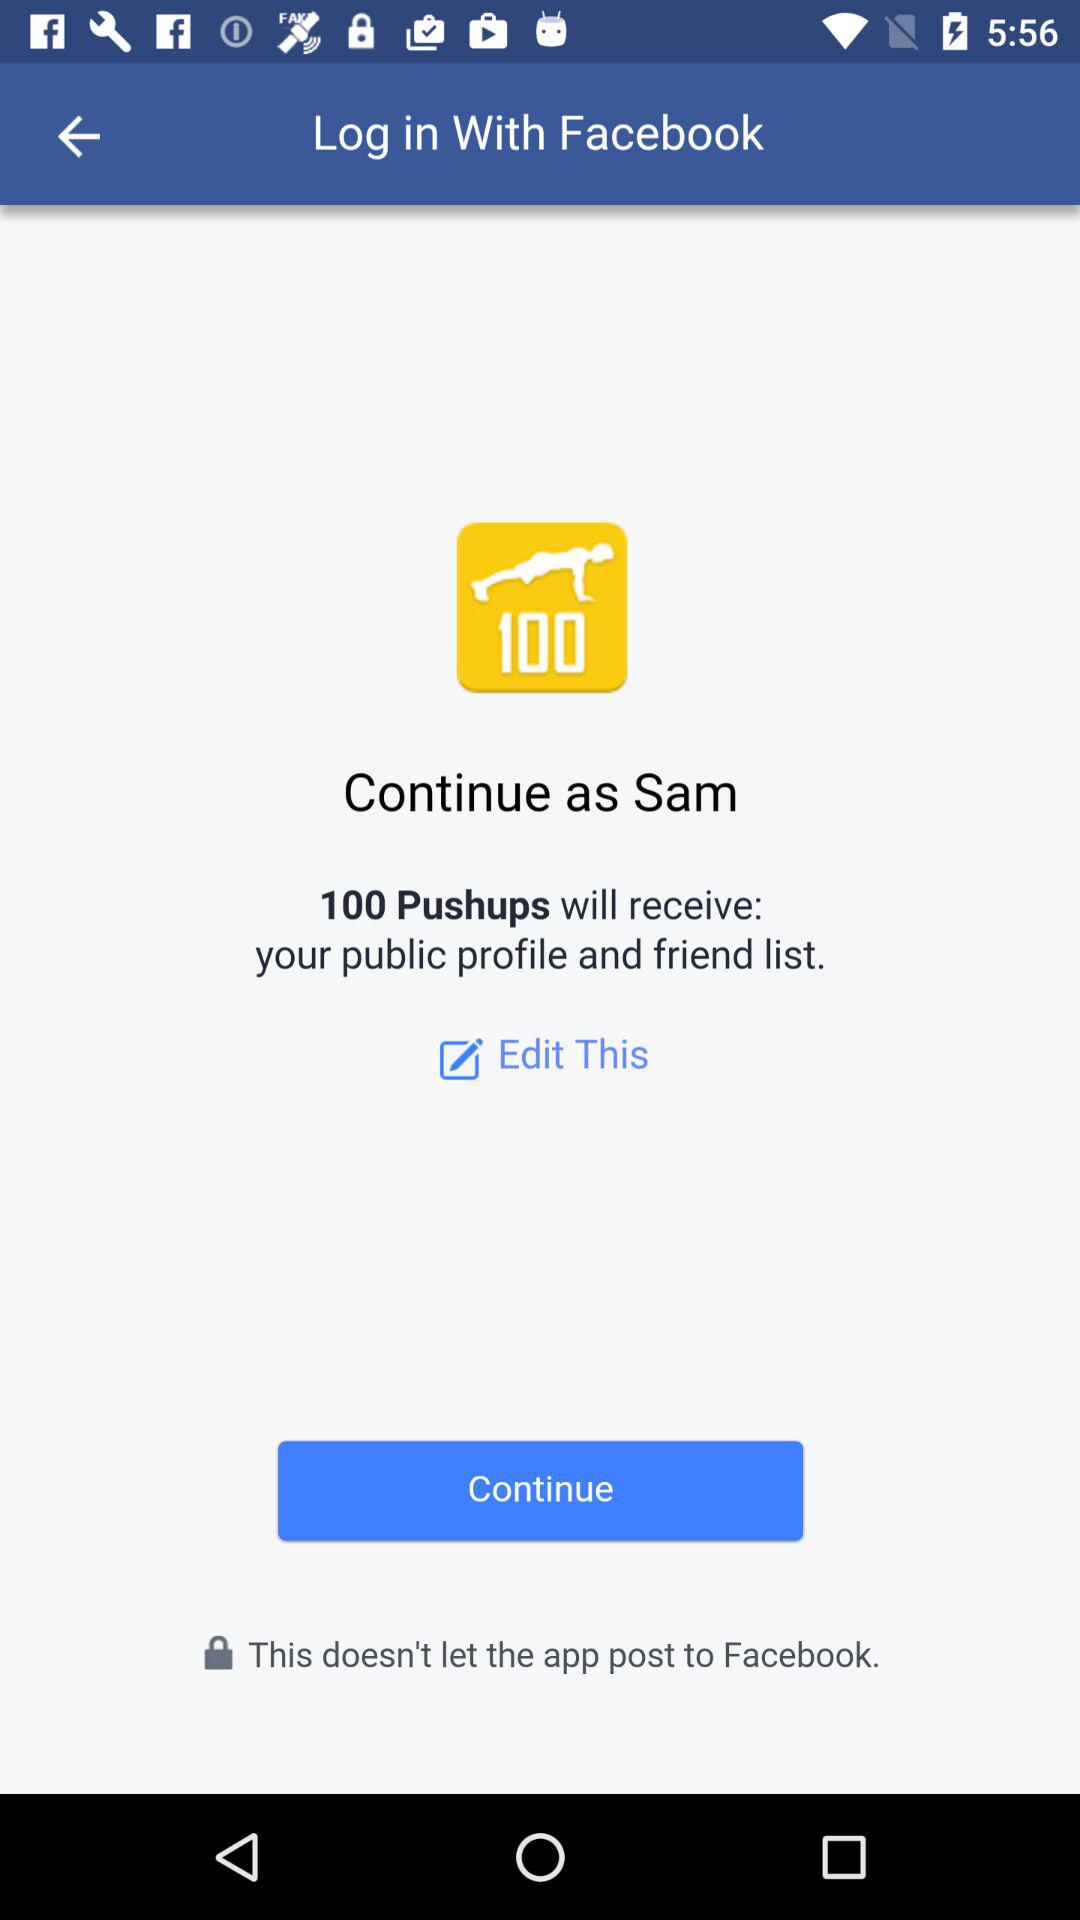How many pushups has "Sam" done?
When the provided information is insufficient, respond with <no answer>. <no answer> 